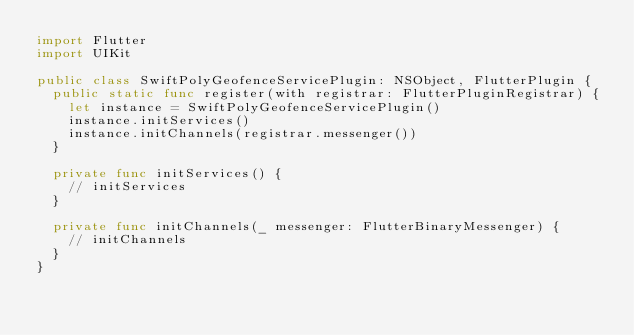<code> <loc_0><loc_0><loc_500><loc_500><_Swift_>import Flutter
import UIKit

public class SwiftPolyGeofenceServicePlugin: NSObject, FlutterPlugin {
  public static func register(with registrar: FlutterPluginRegistrar) {
    let instance = SwiftPolyGeofenceServicePlugin()
    instance.initServices()
    instance.initChannels(registrar.messenger())
  }

  private func initServices() {
    // initServices
  }

  private func initChannels(_ messenger: FlutterBinaryMessenger) {
    // initChannels
  }
}
</code> 